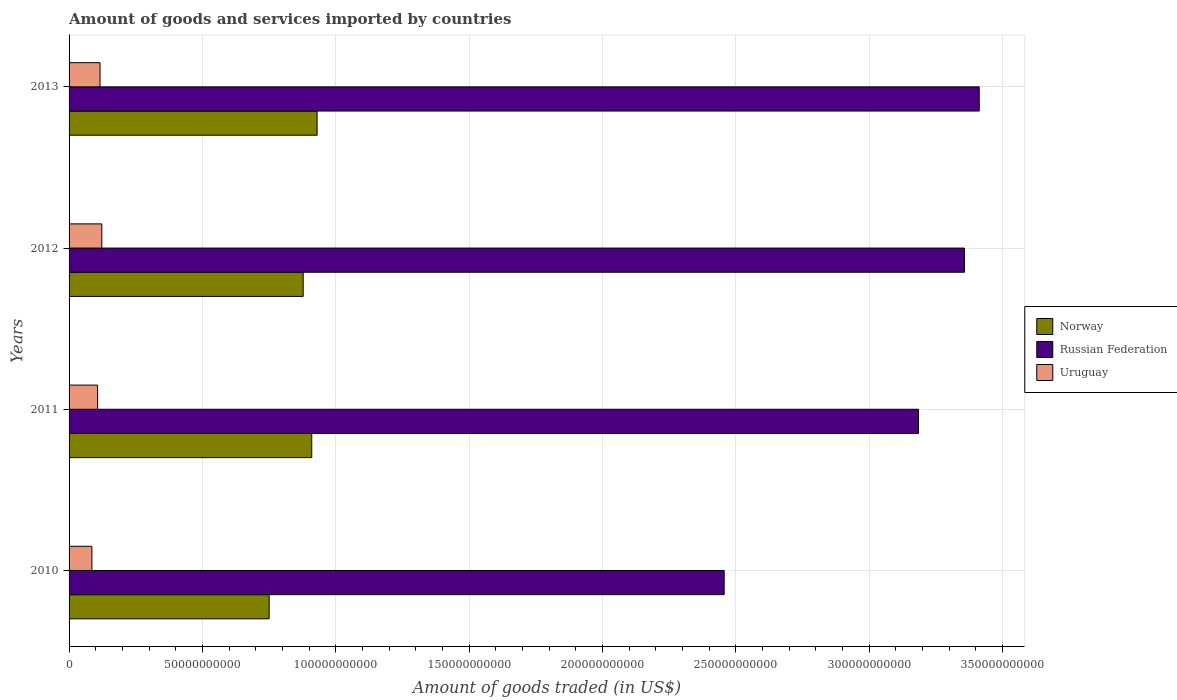How many groups of bars are there?
Your response must be concise. 4. How many bars are there on the 3rd tick from the bottom?
Provide a short and direct response. 3. What is the total amount of goods and services imported in Russian Federation in 2012?
Make the answer very short. 3.36e+11. Across all years, what is the maximum total amount of goods and services imported in Russian Federation?
Make the answer very short. 3.41e+11. Across all years, what is the minimum total amount of goods and services imported in Russian Federation?
Your response must be concise. 2.46e+11. In which year was the total amount of goods and services imported in Uruguay minimum?
Offer a terse response. 2010. What is the total total amount of goods and services imported in Russian Federation in the graph?
Offer a very short reply. 1.24e+12. What is the difference between the total amount of goods and services imported in Uruguay in 2010 and that in 2013?
Give a very brief answer. -3.05e+09. What is the difference between the total amount of goods and services imported in Russian Federation in 2010 and the total amount of goods and services imported in Uruguay in 2013?
Offer a terse response. 2.34e+11. What is the average total amount of goods and services imported in Norway per year?
Offer a terse response. 8.67e+1. In the year 2010, what is the difference between the total amount of goods and services imported in Russian Federation and total amount of goods and services imported in Norway?
Your answer should be compact. 1.71e+11. In how many years, is the total amount of goods and services imported in Uruguay greater than 70000000000 US$?
Your answer should be very brief. 0. What is the ratio of the total amount of goods and services imported in Uruguay in 2010 to that in 2011?
Make the answer very short. 0.8. Is the difference between the total amount of goods and services imported in Russian Federation in 2010 and 2012 greater than the difference between the total amount of goods and services imported in Norway in 2010 and 2012?
Give a very brief answer. No. What is the difference between the highest and the second highest total amount of goods and services imported in Uruguay?
Provide a short and direct response. 6.69e+08. What is the difference between the highest and the lowest total amount of goods and services imported in Russian Federation?
Provide a succinct answer. 9.57e+1. In how many years, is the total amount of goods and services imported in Russian Federation greater than the average total amount of goods and services imported in Russian Federation taken over all years?
Give a very brief answer. 3. Is the sum of the total amount of goods and services imported in Uruguay in 2010 and 2012 greater than the maximum total amount of goods and services imported in Norway across all years?
Your response must be concise. No. What does the 1st bar from the top in 2010 represents?
Your response must be concise. Uruguay. Is it the case that in every year, the sum of the total amount of goods and services imported in Russian Federation and total amount of goods and services imported in Uruguay is greater than the total amount of goods and services imported in Norway?
Give a very brief answer. Yes. What is the difference between two consecutive major ticks on the X-axis?
Your answer should be very brief. 5.00e+1. Does the graph contain any zero values?
Your answer should be compact. No. Where does the legend appear in the graph?
Your answer should be compact. Center right. What is the title of the graph?
Offer a very short reply. Amount of goods and services imported by countries. Does "North America" appear as one of the legend labels in the graph?
Give a very brief answer. No. What is the label or title of the X-axis?
Give a very brief answer. Amount of goods traded (in US$). What is the label or title of the Y-axis?
Make the answer very short. Years. What is the Amount of goods traded (in US$) of Norway in 2010?
Provide a short and direct response. 7.50e+1. What is the Amount of goods traded (in US$) of Russian Federation in 2010?
Make the answer very short. 2.46e+11. What is the Amount of goods traded (in US$) of Uruguay in 2010?
Give a very brief answer. 8.56e+09. What is the Amount of goods traded (in US$) in Norway in 2011?
Your answer should be very brief. 9.10e+1. What is the Amount of goods traded (in US$) in Russian Federation in 2011?
Keep it short and to the point. 3.19e+11. What is the Amount of goods traded (in US$) in Uruguay in 2011?
Offer a terse response. 1.07e+1. What is the Amount of goods traded (in US$) of Norway in 2012?
Your answer should be very brief. 8.78e+1. What is the Amount of goods traded (in US$) of Russian Federation in 2012?
Make the answer very short. 3.36e+11. What is the Amount of goods traded (in US$) in Uruguay in 2012?
Make the answer very short. 1.23e+1. What is the Amount of goods traded (in US$) in Norway in 2013?
Keep it short and to the point. 9.30e+1. What is the Amount of goods traded (in US$) of Russian Federation in 2013?
Provide a short and direct response. 3.41e+11. What is the Amount of goods traded (in US$) of Uruguay in 2013?
Provide a succinct answer. 1.16e+1. Across all years, what is the maximum Amount of goods traded (in US$) of Norway?
Give a very brief answer. 9.30e+1. Across all years, what is the maximum Amount of goods traded (in US$) of Russian Federation?
Make the answer very short. 3.41e+11. Across all years, what is the maximum Amount of goods traded (in US$) of Uruguay?
Offer a terse response. 1.23e+1. Across all years, what is the minimum Amount of goods traded (in US$) in Norway?
Ensure brevity in your answer.  7.50e+1. Across all years, what is the minimum Amount of goods traded (in US$) in Russian Federation?
Keep it short and to the point. 2.46e+11. Across all years, what is the minimum Amount of goods traded (in US$) of Uruguay?
Your answer should be compact. 8.56e+09. What is the total Amount of goods traded (in US$) of Norway in the graph?
Provide a short and direct response. 3.47e+11. What is the total Amount of goods traded (in US$) in Russian Federation in the graph?
Provide a short and direct response. 1.24e+12. What is the total Amount of goods traded (in US$) of Uruguay in the graph?
Ensure brevity in your answer.  4.31e+1. What is the difference between the Amount of goods traded (in US$) of Norway in 2010 and that in 2011?
Your answer should be compact. -1.60e+1. What is the difference between the Amount of goods traded (in US$) of Russian Federation in 2010 and that in 2011?
Provide a short and direct response. -7.29e+1. What is the difference between the Amount of goods traded (in US$) in Uruguay in 2010 and that in 2011?
Provide a succinct answer. -2.15e+09. What is the difference between the Amount of goods traded (in US$) of Norway in 2010 and that in 2012?
Keep it short and to the point. -1.28e+1. What is the difference between the Amount of goods traded (in US$) of Russian Federation in 2010 and that in 2012?
Provide a succinct answer. -9.01e+1. What is the difference between the Amount of goods traded (in US$) of Uruguay in 2010 and that in 2012?
Your response must be concise. -3.72e+09. What is the difference between the Amount of goods traded (in US$) of Norway in 2010 and that in 2013?
Give a very brief answer. -1.80e+1. What is the difference between the Amount of goods traded (in US$) in Russian Federation in 2010 and that in 2013?
Keep it short and to the point. -9.57e+1. What is the difference between the Amount of goods traded (in US$) of Uruguay in 2010 and that in 2013?
Make the answer very short. -3.05e+09. What is the difference between the Amount of goods traded (in US$) of Norway in 2011 and that in 2012?
Your answer should be very brief. 3.21e+09. What is the difference between the Amount of goods traded (in US$) of Russian Federation in 2011 and that in 2012?
Offer a very short reply. -1.72e+1. What is the difference between the Amount of goods traded (in US$) in Uruguay in 2011 and that in 2012?
Your response must be concise. -1.57e+09. What is the difference between the Amount of goods traded (in US$) in Norway in 2011 and that in 2013?
Provide a succinct answer. -2.00e+09. What is the difference between the Amount of goods traded (in US$) in Russian Federation in 2011 and that in 2013?
Offer a terse response. -2.28e+1. What is the difference between the Amount of goods traded (in US$) of Uruguay in 2011 and that in 2013?
Give a very brief answer. -9.04e+08. What is the difference between the Amount of goods traded (in US$) in Norway in 2012 and that in 2013?
Your response must be concise. -5.22e+09. What is the difference between the Amount of goods traded (in US$) of Russian Federation in 2012 and that in 2013?
Provide a short and direct response. -5.57e+09. What is the difference between the Amount of goods traded (in US$) in Uruguay in 2012 and that in 2013?
Your answer should be very brief. 6.69e+08. What is the difference between the Amount of goods traded (in US$) of Norway in 2010 and the Amount of goods traded (in US$) of Russian Federation in 2011?
Ensure brevity in your answer.  -2.44e+11. What is the difference between the Amount of goods traded (in US$) of Norway in 2010 and the Amount of goods traded (in US$) of Uruguay in 2011?
Ensure brevity in your answer.  6.43e+1. What is the difference between the Amount of goods traded (in US$) of Russian Federation in 2010 and the Amount of goods traded (in US$) of Uruguay in 2011?
Give a very brief answer. 2.35e+11. What is the difference between the Amount of goods traded (in US$) of Norway in 2010 and the Amount of goods traded (in US$) of Russian Federation in 2012?
Offer a terse response. -2.61e+11. What is the difference between the Amount of goods traded (in US$) of Norway in 2010 and the Amount of goods traded (in US$) of Uruguay in 2012?
Provide a short and direct response. 6.28e+1. What is the difference between the Amount of goods traded (in US$) of Russian Federation in 2010 and the Amount of goods traded (in US$) of Uruguay in 2012?
Your answer should be very brief. 2.33e+11. What is the difference between the Amount of goods traded (in US$) of Norway in 2010 and the Amount of goods traded (in US$) of Russian Federation in 2013?
Offer a very short reply. -2.66e+11. What is the difference between the Amount of goods traded (in US$) of Norway in 2010 and the Amount of goods traded (in US$) of Uruguay in 2013?
Provide a short and direct response. 6.34e+1. What is the difference between the Amount of goods traded (in US$) of Russian Federation in 2010 and the Amount of goods traded (in US$) of Uruguay in 2013?
Keep it short and to the point. 2.34e+11. What is the difference between the Amount of goods traded (in US$) of Norway in 2011 and the Amount of goods traded (in US$) of Russian Federation in 2012?
Give a very brief answer. -2.45e+11. What is the difference between the Amount of goods traded (in US$) of Norway in 2011 and the Amount of goods traded (in US$) of Uruguay in 2012?
Your response must be concise. 7.87e+1. What is the difference between the Amount of goods traded (in US$) of Russian Federation in 2011 and the Amount of goods traded (in US$) of Uruguay in 2012?
Offer a terse response. 3.06e+11. What is the difference between the Amount of goods traded (in US$) of Norway in 2011 and the Amount of goods traded (in US$) of Russian Federation in 2013?
Give a very brief answer. -2.50e+11. What is the difference between the Amount of goods traded (in US$) in Norway in 2011 and the Amount of goods traded (in US$) in Uruguay in 2013?
Offer a very short reply. 7.94e+1. What is the difference between the Amount of goods traded (in US$) of Russian Federation in 2011 and the Amount of goods traded (in US$) of Uruguay in 2013?
Keep it short and to the point. 3.07e+11. What is the difference between the Amount of goods traded (in US$) in Norway in 2012 and the Amount of goods traded (in US$) in Russian Federation in 2013?
Ensure brevity in your answer.  -2.54e+11. What is the difference between the Amount of goods traded (in US$) in Norway in 2012 and the Amount of goods traded (in US$) in Uruguay in 2013?
Provide a short and direct response. 7.62e+1. What is the difference between the Amount of goods traded (in US$) in Russian Federation in 2012 and the Amount of goods traded (in US$) in Uruguay in 2013?
Give a very brief answer. 3.24e+11. What is the average Amount of goods traded (in US$) of Norway per year?
Provide a succinct answer. 8.67e+1. What is the average Amount of goods traded (in US$) of Russian Federation per year?
Your answer should be very brief. 3.10e+11. What is the average Amount of goods traded (in US$) of Uruguay per year?
Your answer should be very brief. 1.08e+1. In the year 2010, what is the difference between the Amount of goods traded (in US$) in Norway and Amount of goods traded (in US$) in Russian Federation?
Ensure brevity in your answer.  -1.71e+11. In the year 2010, what is the difference between the Amount of goods traded (in US$) in Norway and Amount of goods traded (in US$) in Uruguay?
Your answer should be compact. 6.65e+1. In the year 2010, what is the difference between the Amount of goods traded (in US$) in Russian Federation and Amount of goods traded (in US$) in Uruguay?
Provide a short and direct response. 2.37e+11. In the year 2011, what is the difference between the Amount of goods traded (in US$) of Norway and Amount of goods traded (in US$) of Russian Federation?
Keep it short and to the point. -2.28e+11. In the year 2011, what is the difference between the Amount of goods traded (in US$) of Norway and Amount of goods traded (in US$) of Uruguay?
Your answer should be compact. 8.03e+1. In the year 2011, what is the difference between the Amount of goods traded (in US$) in Russian Federation and Amount of goods traded (in US$) in Uruguay?
Offer a terse response. 3.08e+11. In the year 2012, what is the difference between the Amount of goods traded (in US$) of Norway and Amount of goods traded (in US$) of Russian Federation?
Make the answer very short. -2.48e+11. In the year 2012, what is the difference between the Amount of goods traded (in US$) in Norway and Amount of goods traded (in US$) in Uruguay?
Give a very brief answer. 7.55e+1. In the year 2012, what is the difference between the Amount of goods traded (in US$) of Russian Federation and Amount of goods traded (in US$) of Uruguay?
Offer a terse response. 3.23e+11. In the year 2013, what is the difference between the Amount of goods traded (in US$) of Norway and Amount of goods traded (in US$) of Russian Federation?
Give a very brief answer. -2.48e+11. In the year 2013, what is the difference between the Amount of goods traded (in US$) of Norway and Amount of goods traded (in US$) of Uruguay?
Ensure brevity in your answer.  8.14e+1. In the year 2013, what is the difference between the Amount of goods traded (in US$) in Russian Federation and Amount of goods traded (in US$) in Uruguay?
Offer a terse response. 3.30e+11. What is the ratio of the Amount of goods traded (in US$) in Norway in 2010 to that in 2011?
Your response must be concise. 0.82. What is the ratio of the Amount of goods traded (in US$) of Russian Federation in 2010 to that in 2011?
Ensure brevity in your answer.  0.77. What is the ratio of the Amount of goods traded (in US$) of Uruguay in 2010 to that in 2011?
Offer a very short reply. 0.8. What is the ratio of the Amount of goods traded (in US$) in Norway in 2010 to that in 2012?
Your answer should be compact. 0.85. What is the ratio of the Amount of goods traded (in US$) of Russian Federation in 2010 to that in 2012?
Give a very brief answer. 0.73. What is the ratio of the Amount of goods traded (in US$) in Uruguay in 2010 to that in 2012?
Your response must be concise. 0.7. What is the ratio of the Amount of goods traded (in US$) in Norway in 2010 to that in 2013?
Your answer should be very brief. 0.81. What is the ratio of the Amount of goods traded (in US$) of Russian Federation in 2010 to that in 2013?
Your answer should be compact. 0.72. What is the ratio of the Amount of goods traded (in US$) in Uruguay in 2010 to that in 2013?
Your answer should be very brief. 0.74. What is the ratio of the Amount of goods traded (in US$) in Norway in 2011 to that in 2012?
Offer a very short reply. 1.04. What is the ratio of the Amount of goods traded (in US$) of Russian Federation in 2011 to that in 2012?
Your answer should be compact. 0.95. What is the ratio of the Amount of goods traded (in US$) of Uruguay in 2011 to that in 2012?
Keep it short and to the point. 0.87. What is the ratio of the Amount of goods traded (in US$) of Norway in 2011 to that in 2013?
Ensure brevity in your answer.  0.98. What is the ratio of the Amount of goods traded (in US$) of Uruguay in 2011 to that in 2013?
Make the answer very short. 0.92. What is the ratio of the Amount of goods traded (in US$) in Norway in 2012 to that in 2013?
Ensure brevity in your answer.  0.94. What is the ratio of the Amount of goods traded (in US$) in Russian Federation in 2012 to that in 2013?
Make the answer very short. 0.98. What is the ratio of the Amount of goods traded (in US$) in Uruguay in 2012 to that in 2013?
Offer a terse response. 1.06. What is the difference between the highest and the second highest Amount of goods traded (in US$) in Norway?
Provide a short and direct response. 2.00e+09. What is the difference between the highest and the second highest Amount of goods traded (in US$) of Russian Federation?
Keep it short and to the point. 5.57e+09. What is the difference between the highest and the second highest Amount of goods traded (in US$) in Uruguay?
Give a very brief answer. 6.69e+08. What is the difference between the highest and the lowest Amount of goods traded (in US$) in Norway?
Provide a short and direct response. 1.80e+1. What is the difference between the highest and the lowest Amount of goods traded (in US$) of Russian Federation?
Keep it short and to the point. 9.57e+1. What is the difference between the highest and the lowest Amount of goods traded (in US$) in Uruguay?
Your answer should be very brief. 3.72e+09. 